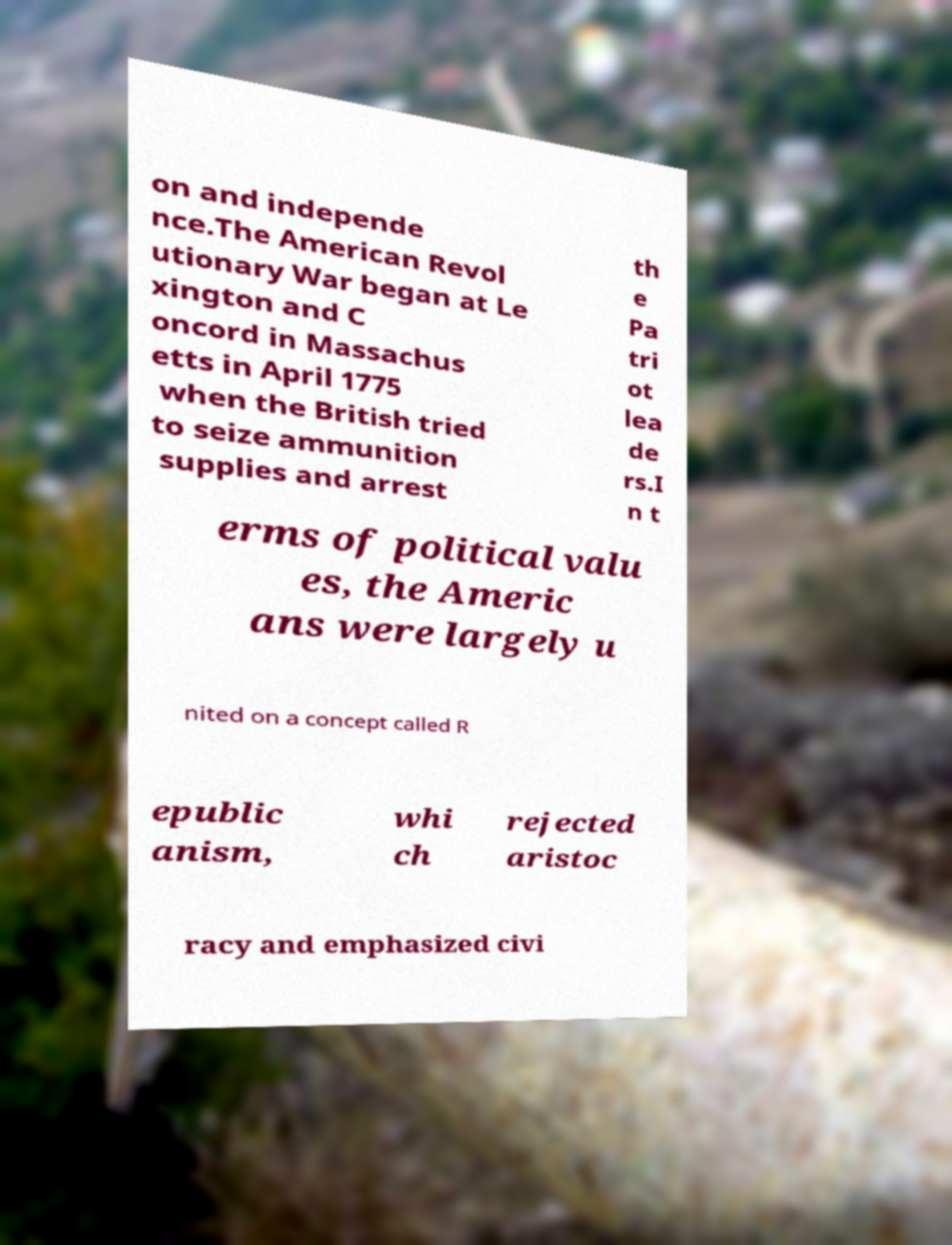There's text embedded in this image that I need extracted. Can you transcribe it verbatim? on and independe nce.The American Revol utionary War began at Le xington and C oncord in Massachus etts in April 1775 when the British tried to seize ammunition supplies and arrest th e Pa tri ot lea de rs.I n t erms of political valu es, the Americ ans were largely u nited on a concept called R epublic anism, whi ch rejected aristoc racy and emphasized civi 